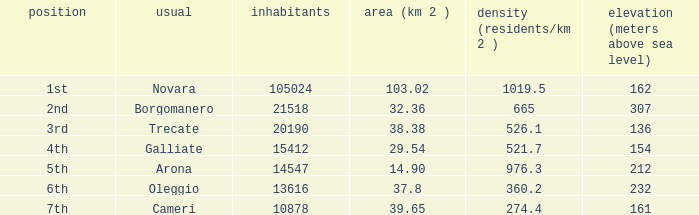Which common covers an area (km2) of 10 Novara. 